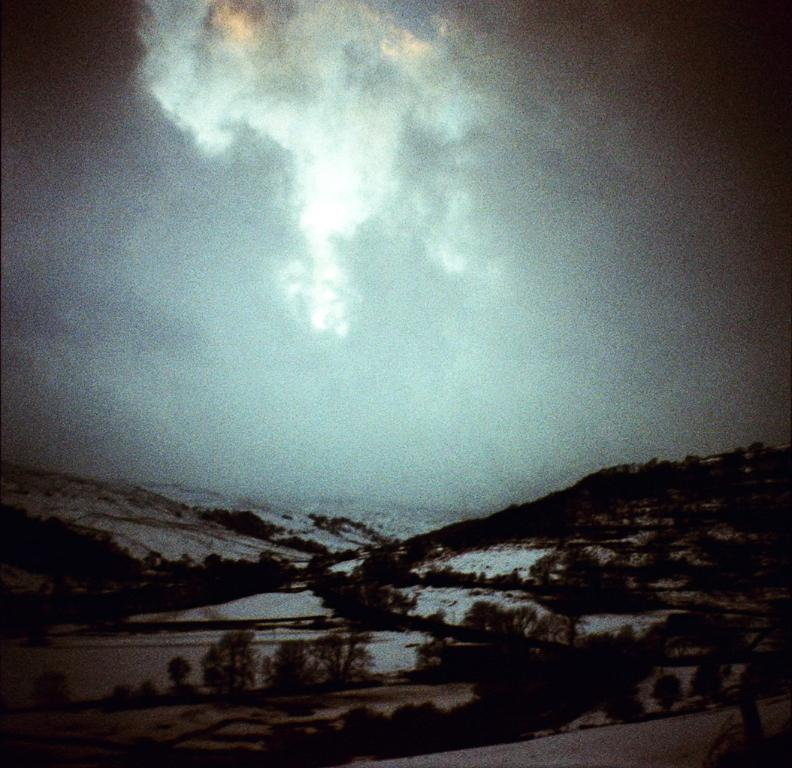What is the main feature of the image? There is a road in the image. What else can be seen besides the road? There are plants, snow on the surface in the background, mountains in the background, and the sky visible in the background. What type of creature can be seen using its sense of smell in the image? There is no creature present in the image, and therefore no such activity can be observed. 